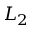<formula> <loc_0><loc_0><loc_500><loc_500>L _ { 2 }</formula> 